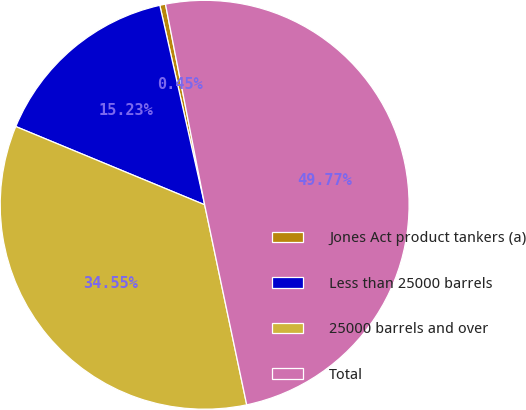Convert chart. <chart><loc_0><loc_0><loc_500><loc_500><pie_chart><fcel>Jones Act product tankers (a)<fcel>Less than 25000 barrels<fcel>25000 barrels and over<fcel>Total<nl><fcel>0.45%<fcel>15.23%<fcel>34.55%<fcel>49.77%<nl></chart> 